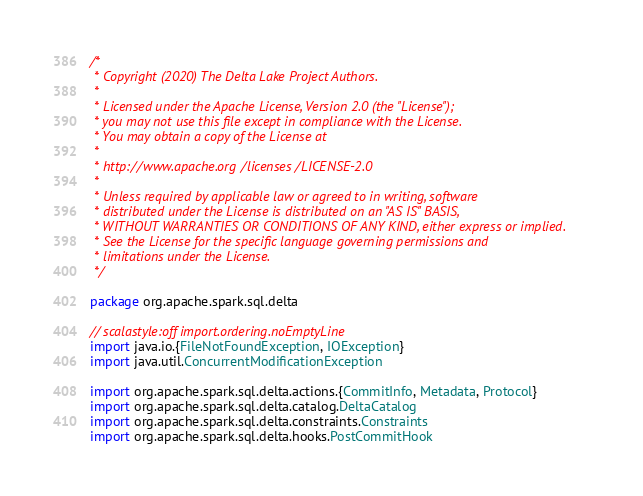Convert code to text. <code><loc_0><loc_0><loc_500><loc_500><_Scala_>/*
 * Copyright (2020) The Delta Lake Project Authors.
 *
 * Licensed under the Apache License, Version 2.0 (the "License");
 * you may not use this file except in compliance with the License.
 * You may obtain a copy of the License at
 *
 * http://www.apache.org/licenses/LICENSE-2.0
 *
 * Unless required by applicable law or agreed to in writing, software
 * distributed under the License is distributed on an "AS IS" BASIS,
 * WITHOUT WARRANTIES OR CONDITIONS OF ANY KIND, either express or implied.
 * See the License for the specific language governing permissions and
 * limitations under the License.
 */

package org.apache.spark.sql.delta

// scalastyle:off import.ordering.noEmptyLine
import java.io.{FileNotFoundException, IOException}
import java.util.ConcurrentModificationException

import org.apache.spark.sql.delta.actions.{CommitInfo, Metadata, Protocol}
import org.apache.spark.sql.delta.catalog.DeltaCatalog
import org.apache.spark.sql.delta.constraints.Constraints
import org.apache.spark.sql.delta.hooks.PostCommitHook</code> 